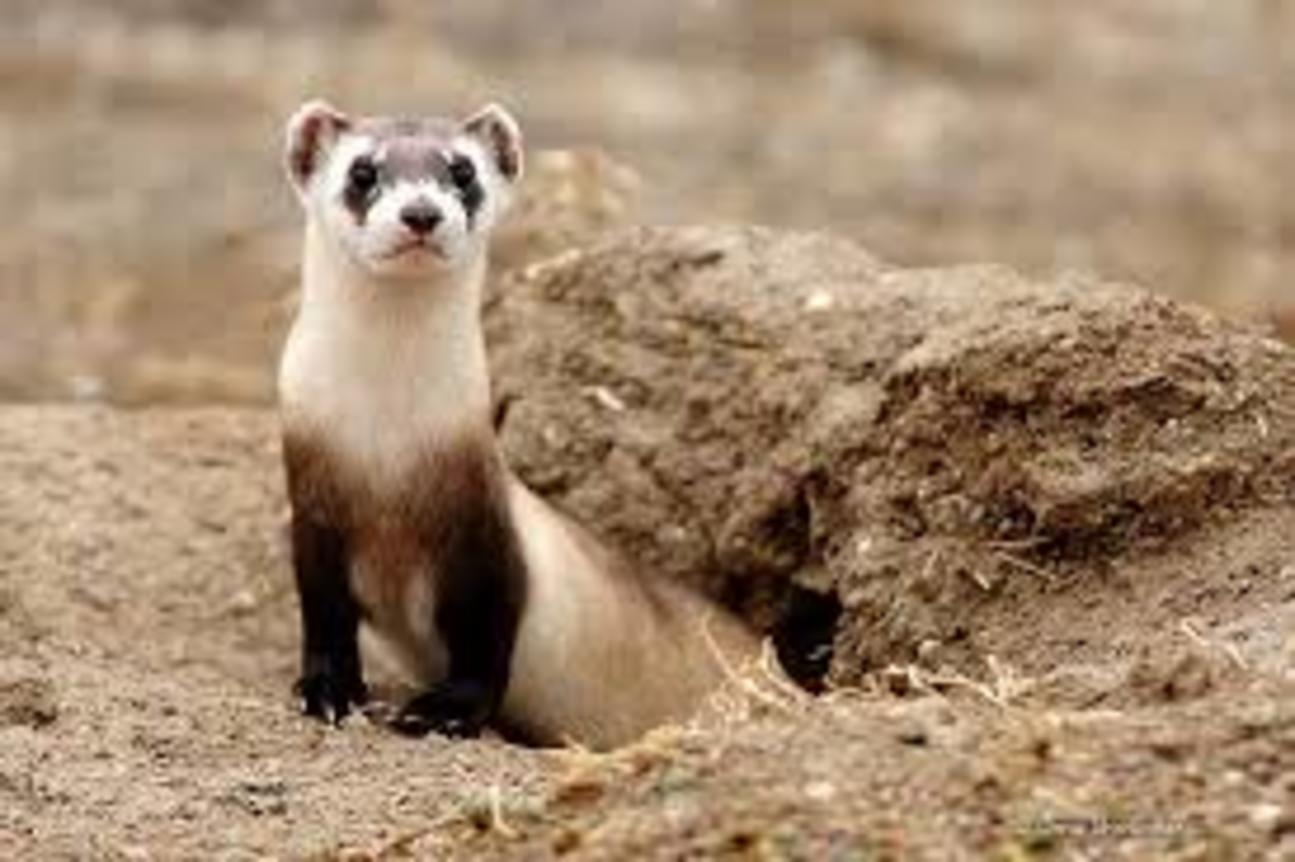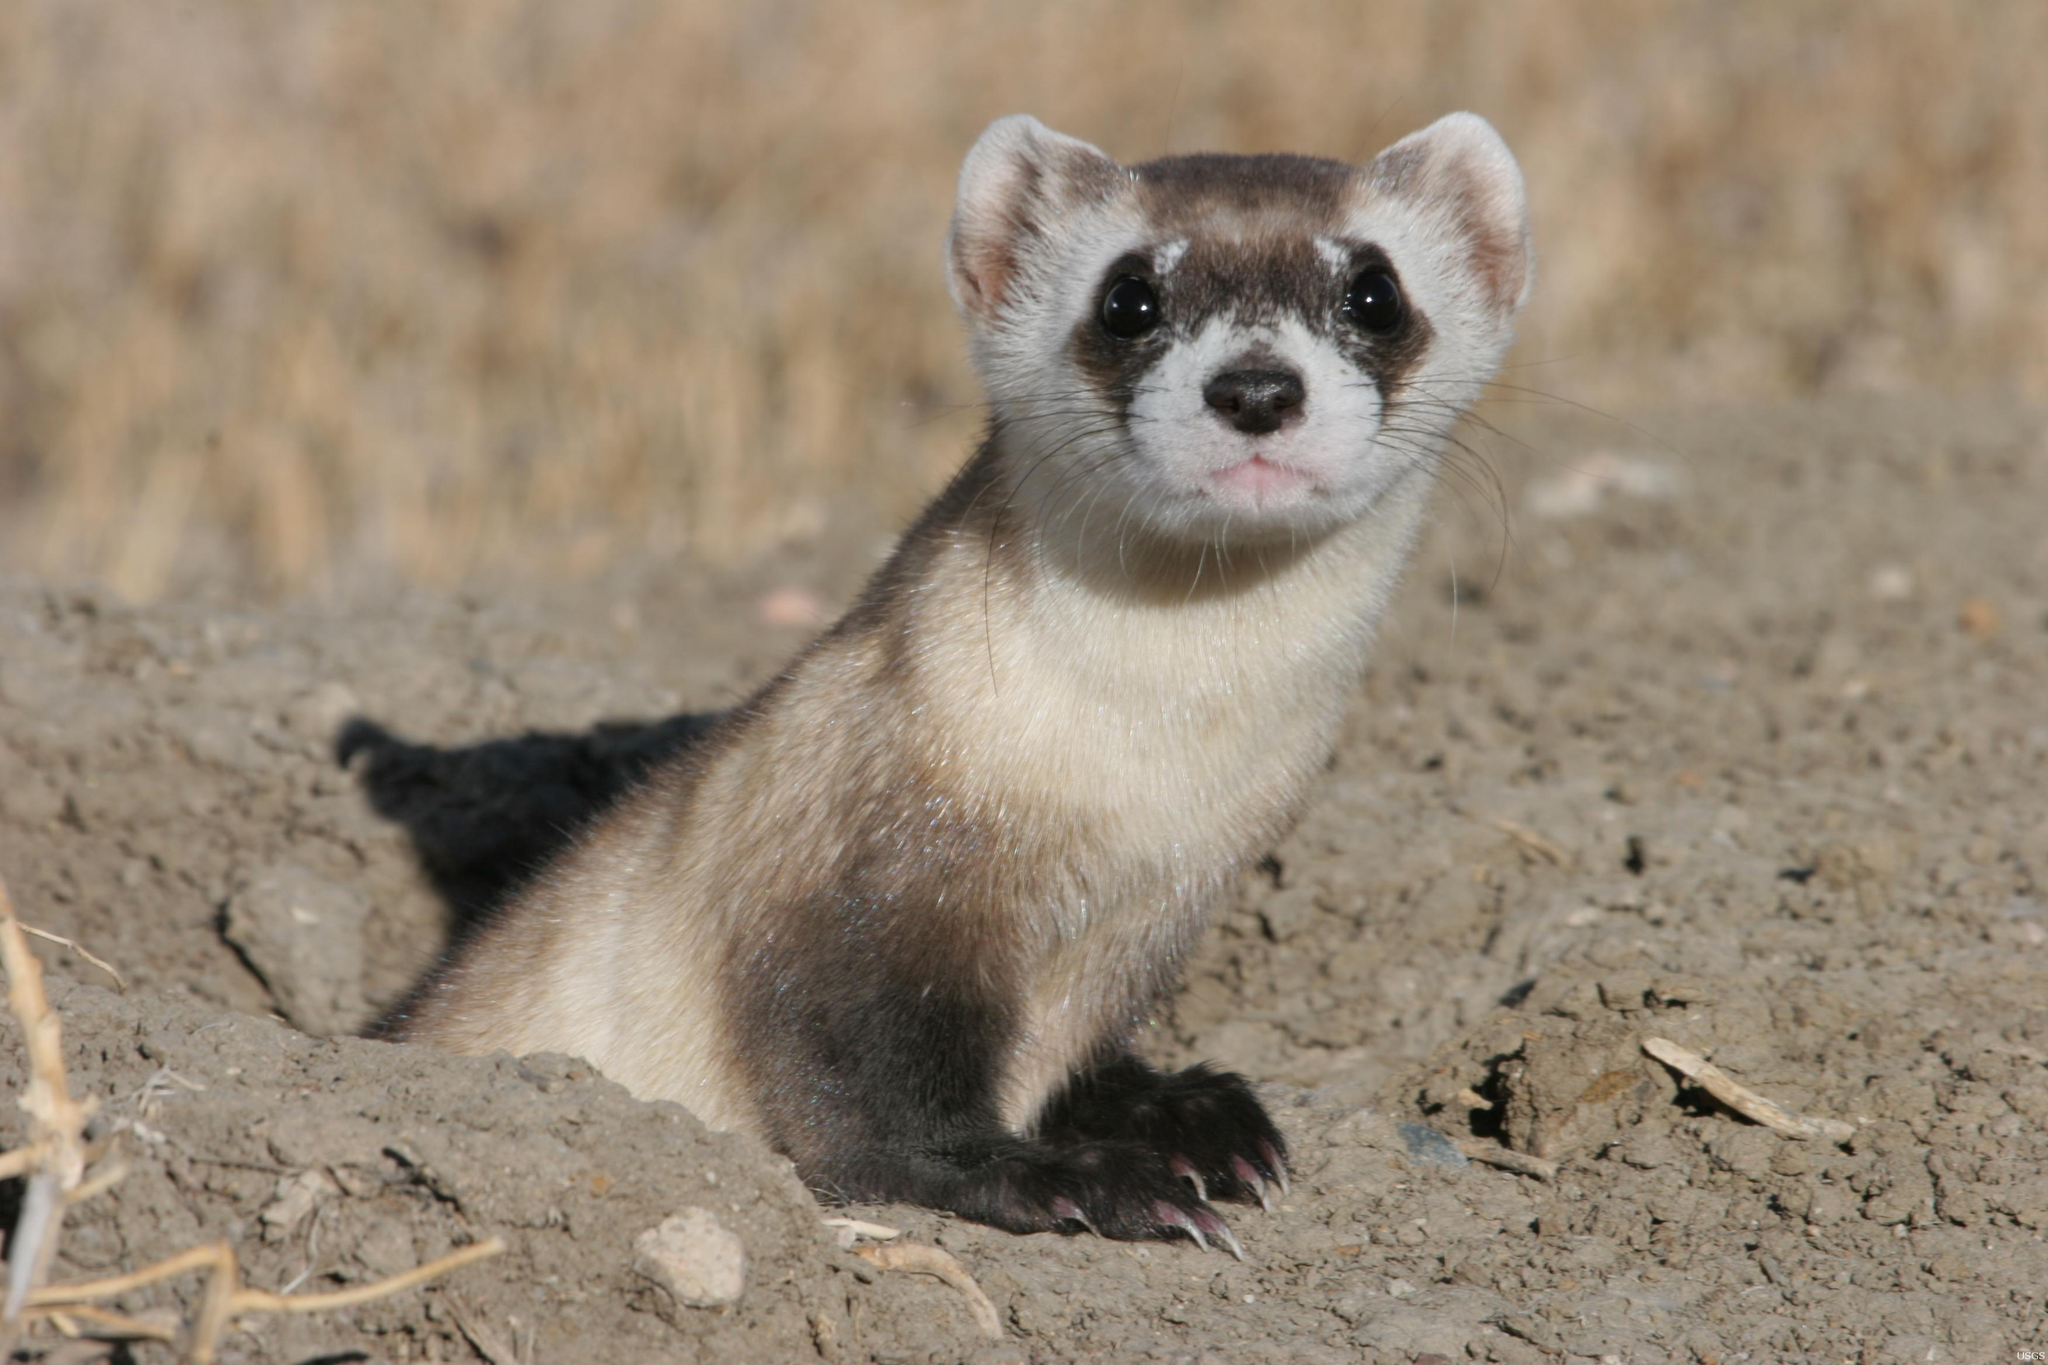The first image is the image on the left, the second image is the image on the right. For the images shown, is this caption "Each image shows exactly one ferret emerging from a hole in the ground." true? Answer yes or no. Yes. The first image is the image on the left, the second image is the image on the right. Considering the images on both sides, is "Both images contain a prairie dog partially submerged in a hole in the ground." valid? Answer yes or no. Yes. 